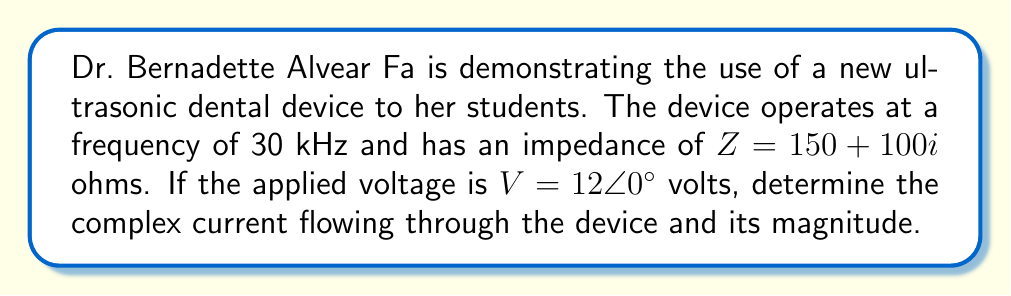Provide a solution to this math problem. To solve this problem, we'll use complex number analysis and Ohm's law. Let's break it down step-by-step:

1) We're given:
   - Frequency: $f = 30$ kHz
   - Impedance: $Z = 150 + 100i$ ohms
   - Voltage: $V = 12\angle 0°$ volts

2) Ohm's law states that $I = \frac{V}{Z}$, where $I$ is current, $V$ is voltage, and $Z$ is impedance.

3) We need to divide the complex voltage by the complex impedance:

   $$I = \frac{12\angle 0°}{150 + 100i}$$

4) To divide complex numbers, we multiply by the complex conjugate of the denominator:

   $$I = \frac{12\angle 0°}{150 + 100i} \cdot \frac{150 - 100i}{150 - 100i}$$

5) Simplify:

   $$I = \frac{12(150 - 100i)}{150^2 + 100^2} = \frac{1800 - 1200i}{32500}$$

6) Separate real and imaginary parts:

   $$I = \frac{1800}{32500} - \frac{1200i}{32500} = 0.0554 - 0.0369i$$

7) To find the magnitude of the current, we use the formula $|I| = \sqrt{a^2 + b^2}$, where $a$ is the real part and $b$ is the imaginary part:

   $$|I| = \sqrt{0.0554^2 + (-0.0369)^2} = 0.0667$$

Thus, the complex current is $0.0554 - 0.0369i$ amperes, with a magnitude of 0.0667 amperes.
Answer: The complex current is $I = 0.0554 - 0.0369i$ amperes, with a magnitude of $|I| = 0.0667$ amperes. 